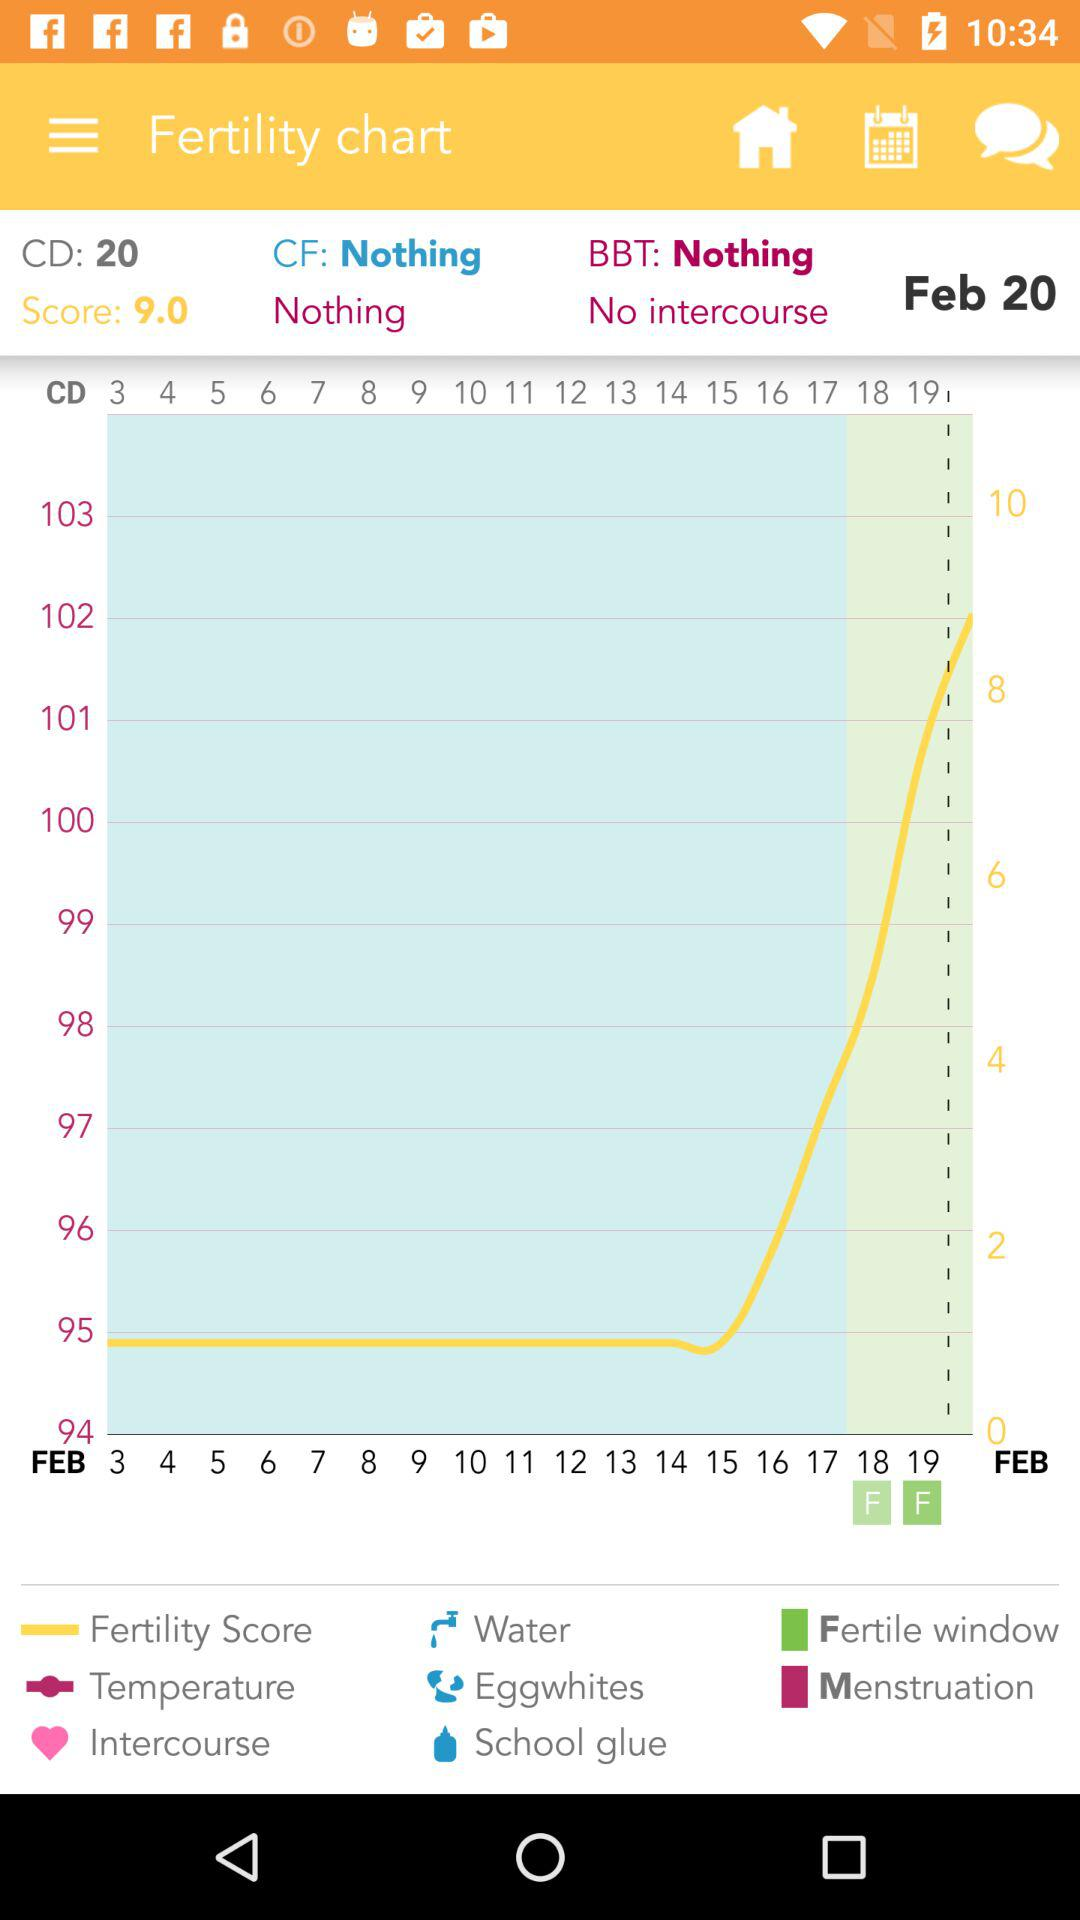What is the name of the application?
When the provided information is insufficient, respond with <no answer>. <no answer> 